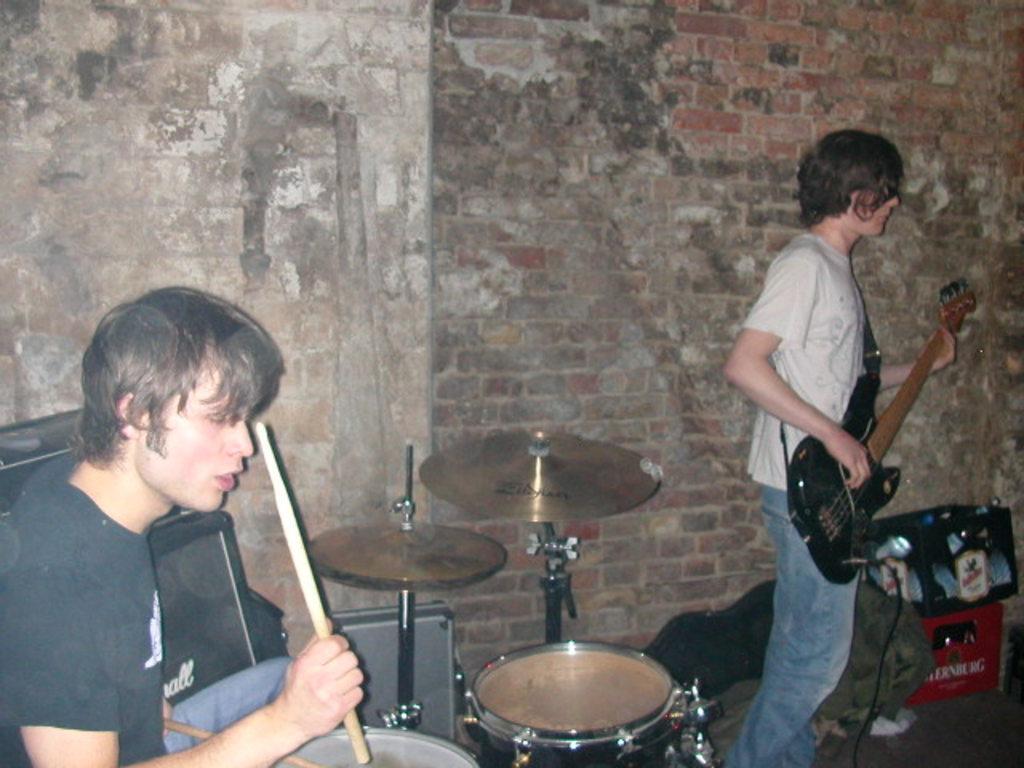Can you describe this image briefly? In this image, In the right side there is a boy who is standing and holding a music instrument which is in black color, In the left side there is a boy sitting and he is holding a stick, There are some music instruments in the middle of the image. 